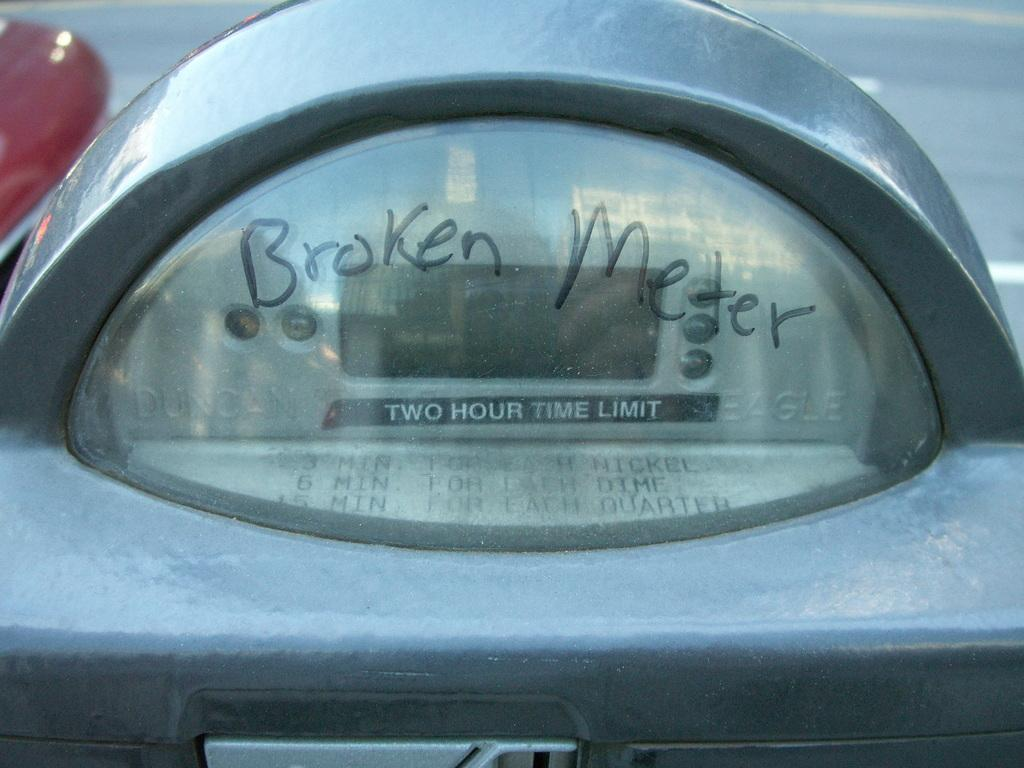<image>
Give a short and clear explanation of the subsequent image. a meter that says broken meter on it 